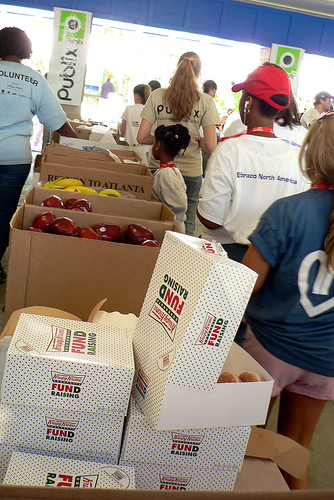<image>
Is there a cap on the person? No. The cap is not positioned on the person. They may be near each other, but the cap is not supported by or resting on top of the person. 